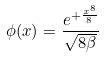<formula> <loc_0><loc_0><loc_500><loc_500>\phi ( x ) = \frac { e ^ { + \frac { x ^ { 8 } } { 8 } } } { \sqrt { 8 \beta } }</formula> 